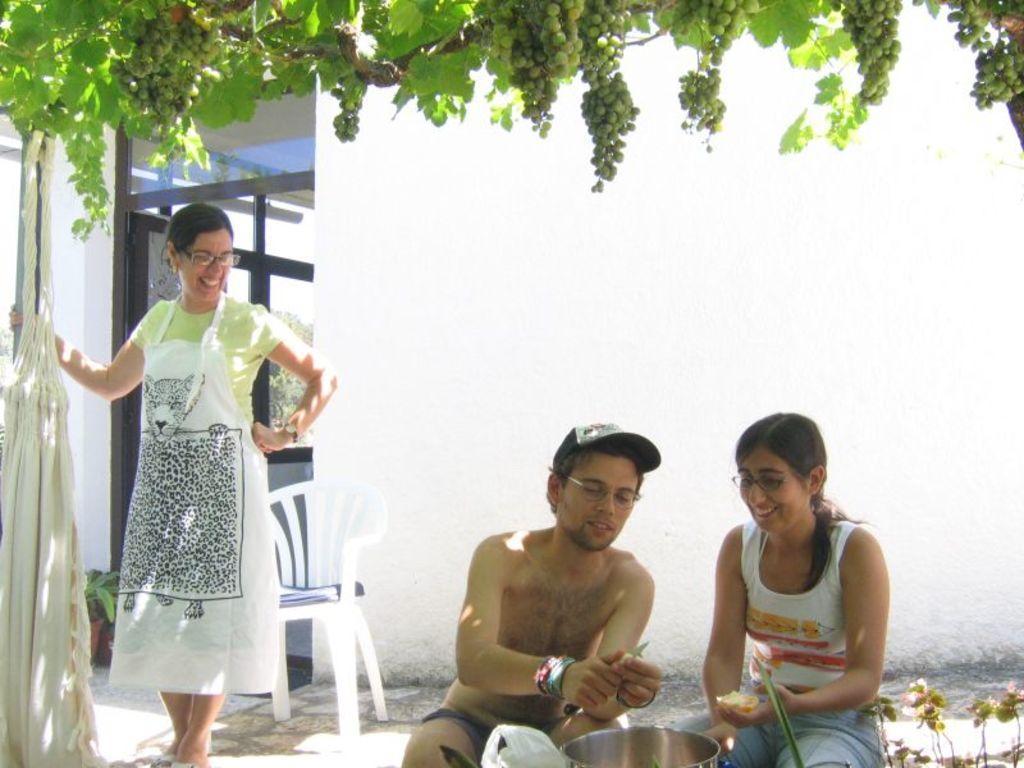Could you give a brief overview of what you see in this image? On the left side a woman is standing and smiling, in the middle a man is sitting and cutting the fruits, he wore cap, beside him a beautiful girl is sitting and smiling, she wore white color top. At the top there are grapes. 